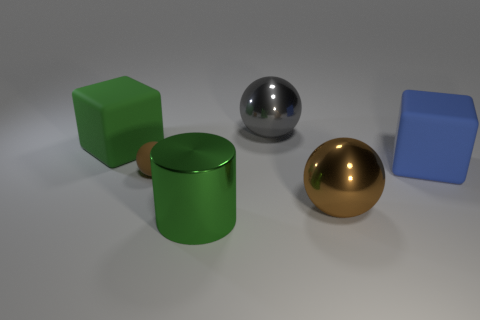Add 2 tiny purple matte blocks. How many objects exist? 8 Subtract all cylinders. How many objects are left? 5 Add 6 big gray balls. How many big gray balls exist? 7 Subtract 0 gray blocks. How many objects are left? 6 Subtract all blocks. Subtract all small brown spheres. How many objects are left? 3 Add 4 green metal objects. How many green metal objects are left? 5 